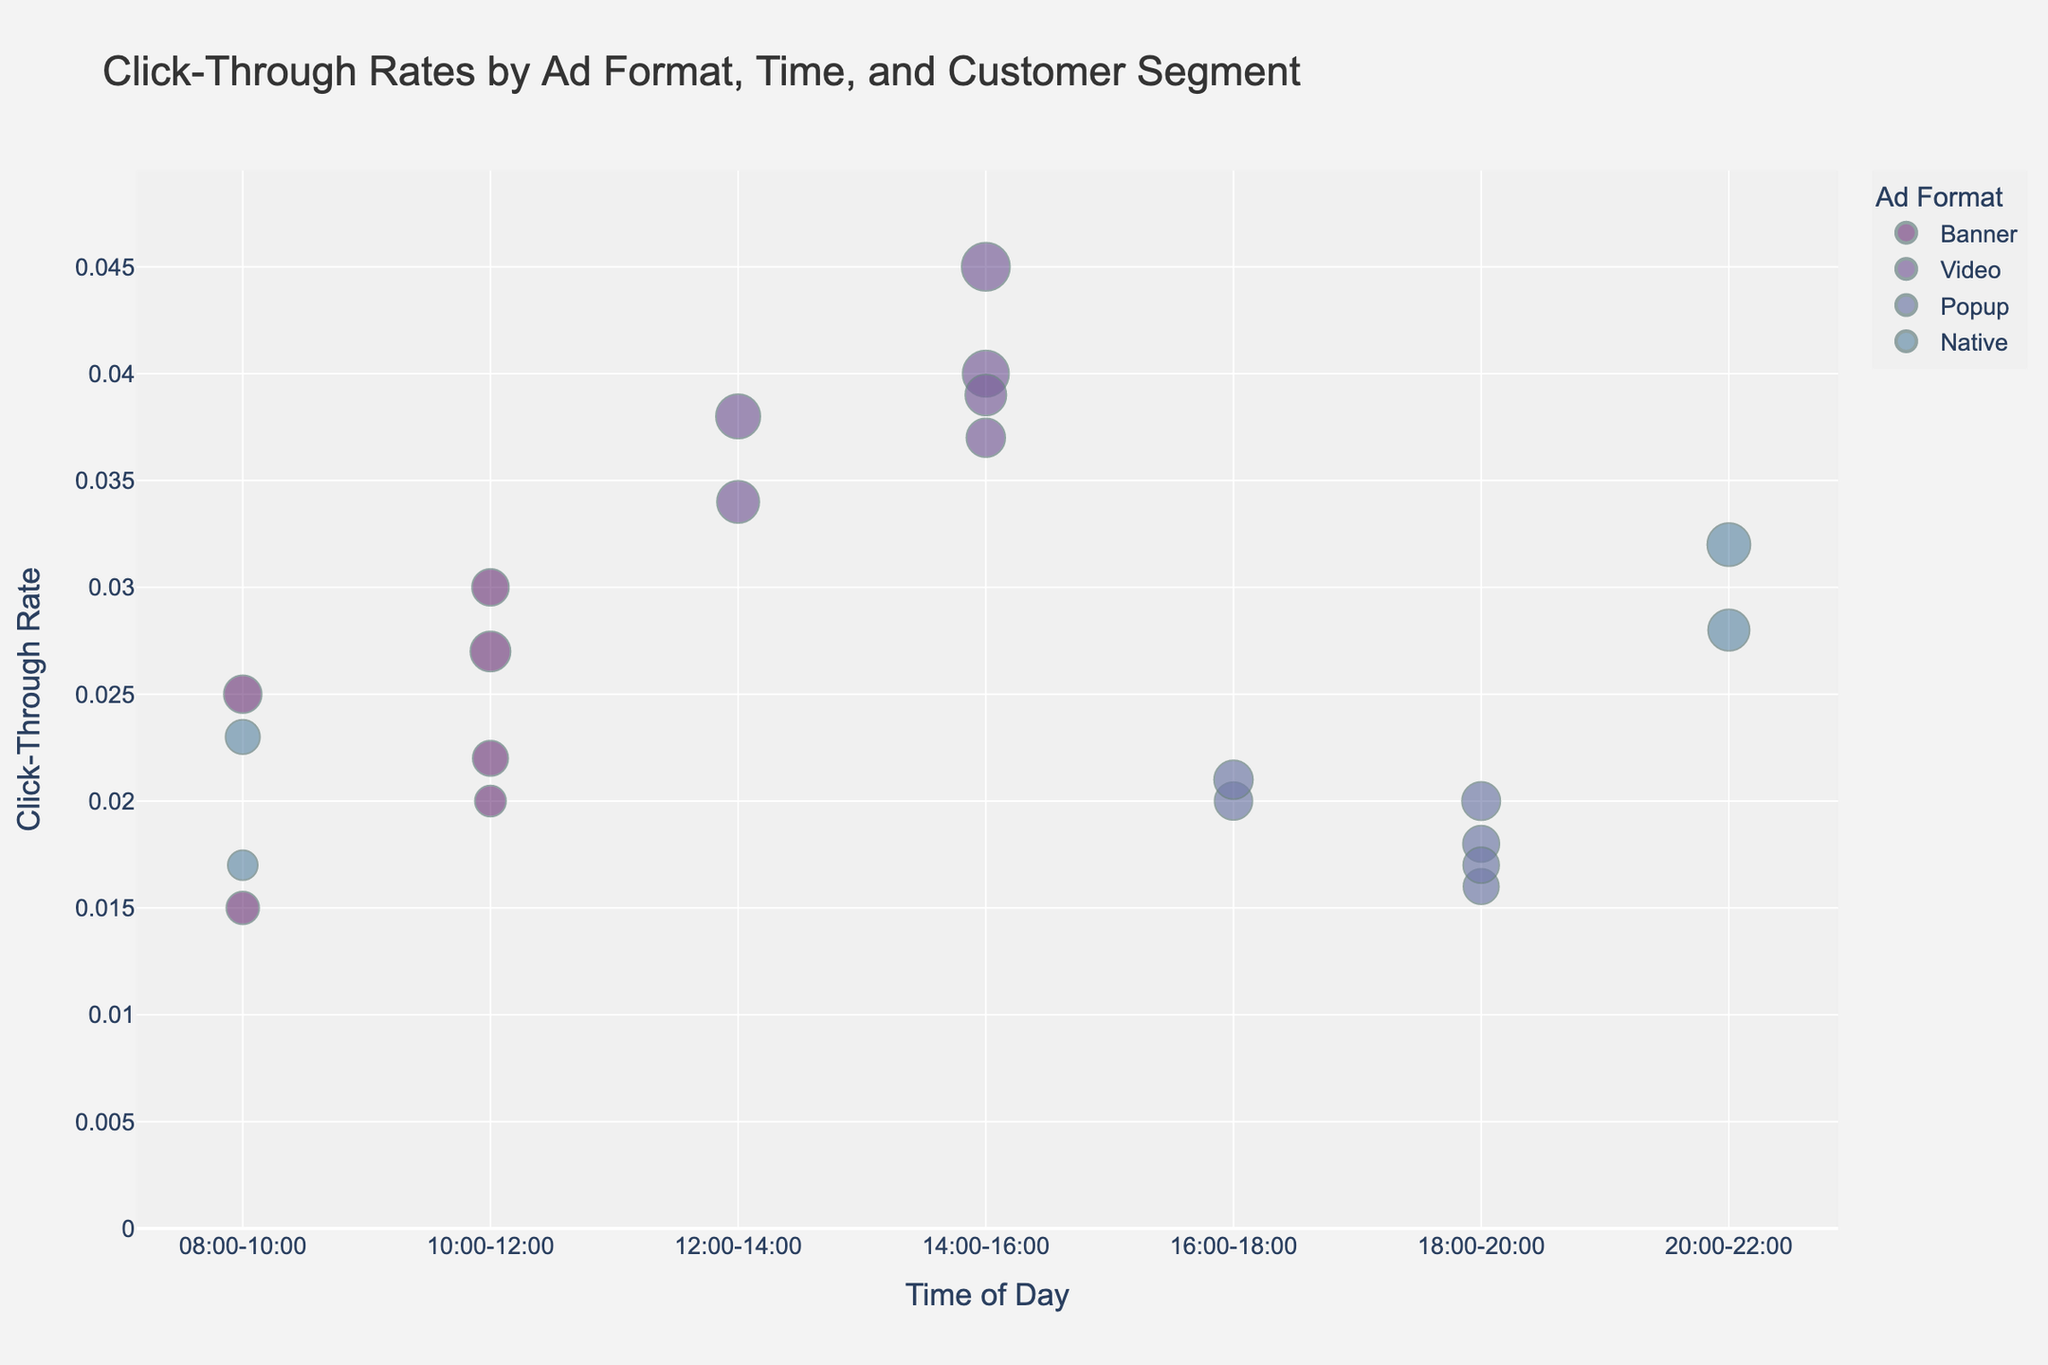What is the title of the figure? The title of the figure is displayed at the top and typically summarizes what the figure is about. In this case, it indicates the subject being analyzed.
Answer: Click-Through Rates by Ad Format, Time, and Customer Segment What time of day has the highest click-through rate? To find the answer, look at the y-axis which represents click-through rate and identify the time period on the x-axis corresponding to the highest point.
Answer: 14:00-16:00 What is the click-through rate for Banner ads between 08:00-10:00 for Women 25-34? Locate the bubble that matches these criteria by looking at the colors and labels. The y-axis value of this bubble gives the click-through rate.
Answer: 0.025 Which ad format generally has the largest bubble sizes? Observe the various bubble sizes for each ad format and identify which format consistently has the larger bubbles. This indicates the size variable associated with each ad format.
Answer: Video Compare the click-through rates of Video and Popup ads for Women 25-34 between 12:00-14:00 and 16:00-18:00 respectively. Which is higher? Find the click-through rates of Video ads for Women 25-34 at 12:00-14:00 and Popup ads for the same segment at 16:00-18:00 by looking at the respective bubbles. Compare the y-axis values.
Answer: Video (0.038) is higher than Popup (0.021) For Men 18-24, which ad format and time results in the highest click-through rate? Look for the highest position (y-value) among all the bubbles labeled as Men 18-24, considering the color that represents different ad formats and their corresponding time slots.
Answer: Video at 14:00-16:00 What are the click-through rates for Native ads between 08:00-10:00 for Men 35-44 and Women 35-44? Identify the Native ad format bubbles for 08:00-10:00 and check their y-axis values for both Men 35-44 and Women 35-44.
Answer: Men 35-44: 0.017, Women 35-44: 0.023 Which customer segment has the lowest click-through rate for Popup ads between 18:00-20:00? Locate the Popup ads for the 18:00-20:00 timeframe and compare the click-through rates (y-axis values) for each customer segment.
Answer: Men 35-44 How does the click-through rate for Video ads compare between Men 18-24 at 12:00-14:00 and Men 35-44 at 14:00-16:00? Identify the bubbles for Video ads at the specified times and customer segments and compare the y-axis values.
Answer: Men 35-44 (0.037) is slightly lower than Men 18-24 (0.034) Which time of day and ad format combination has the highest bubble size? Since bubble size indicates another variable, identify the largest bubble by comparing the sizes visually across all ad formats and times of the day.
Answer: Video at 14:00-16:00 